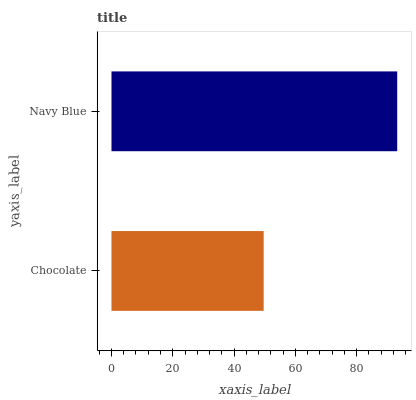Is Chocolate the minimum?
Answer yes or no. Yes. Is Navy Blue the maximum?
Answer yes or no. Yes. Is Navy Blue the minimum?
Answer yes or no. No. Is Navy Blue greater than Chocolate?
Answer yes or no. Yes. Is Chocolate less than Navy Blue?
Answer yes or no. Yes. Is Chocolate greater than Navy Blue?
Answer yes or no. No. Is Navy Blue less than Chocolate?
Answer yes or no. No. Is Navy Blue the high median?
Answer yes or no. Yes. Is Chocolate the low median?
Answer yes or no. Yes. Is Chocolate the high median?
Answer yes or no. No. Is Navy Blue the low median?
Answer yes or no. No. 